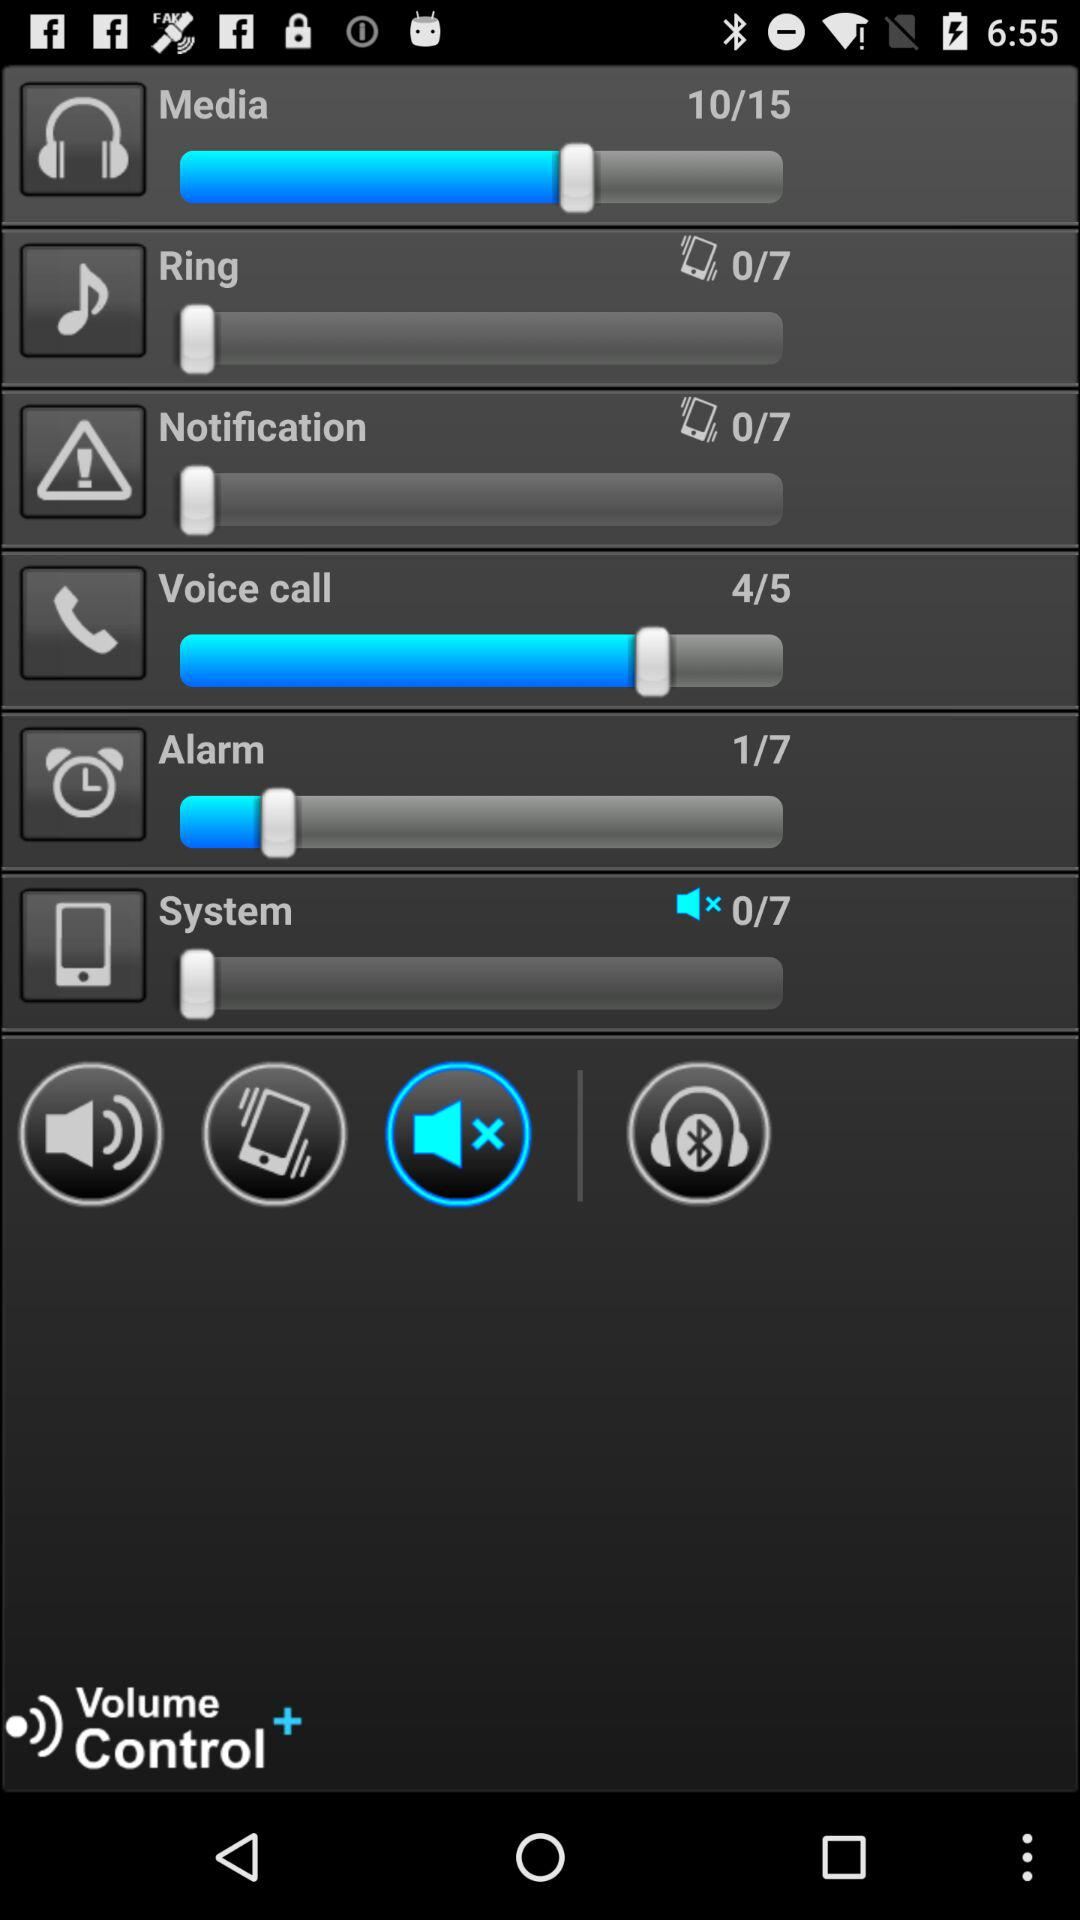How many volume levels in total are there for notification? There are a total of 7 volume levels for notification. 